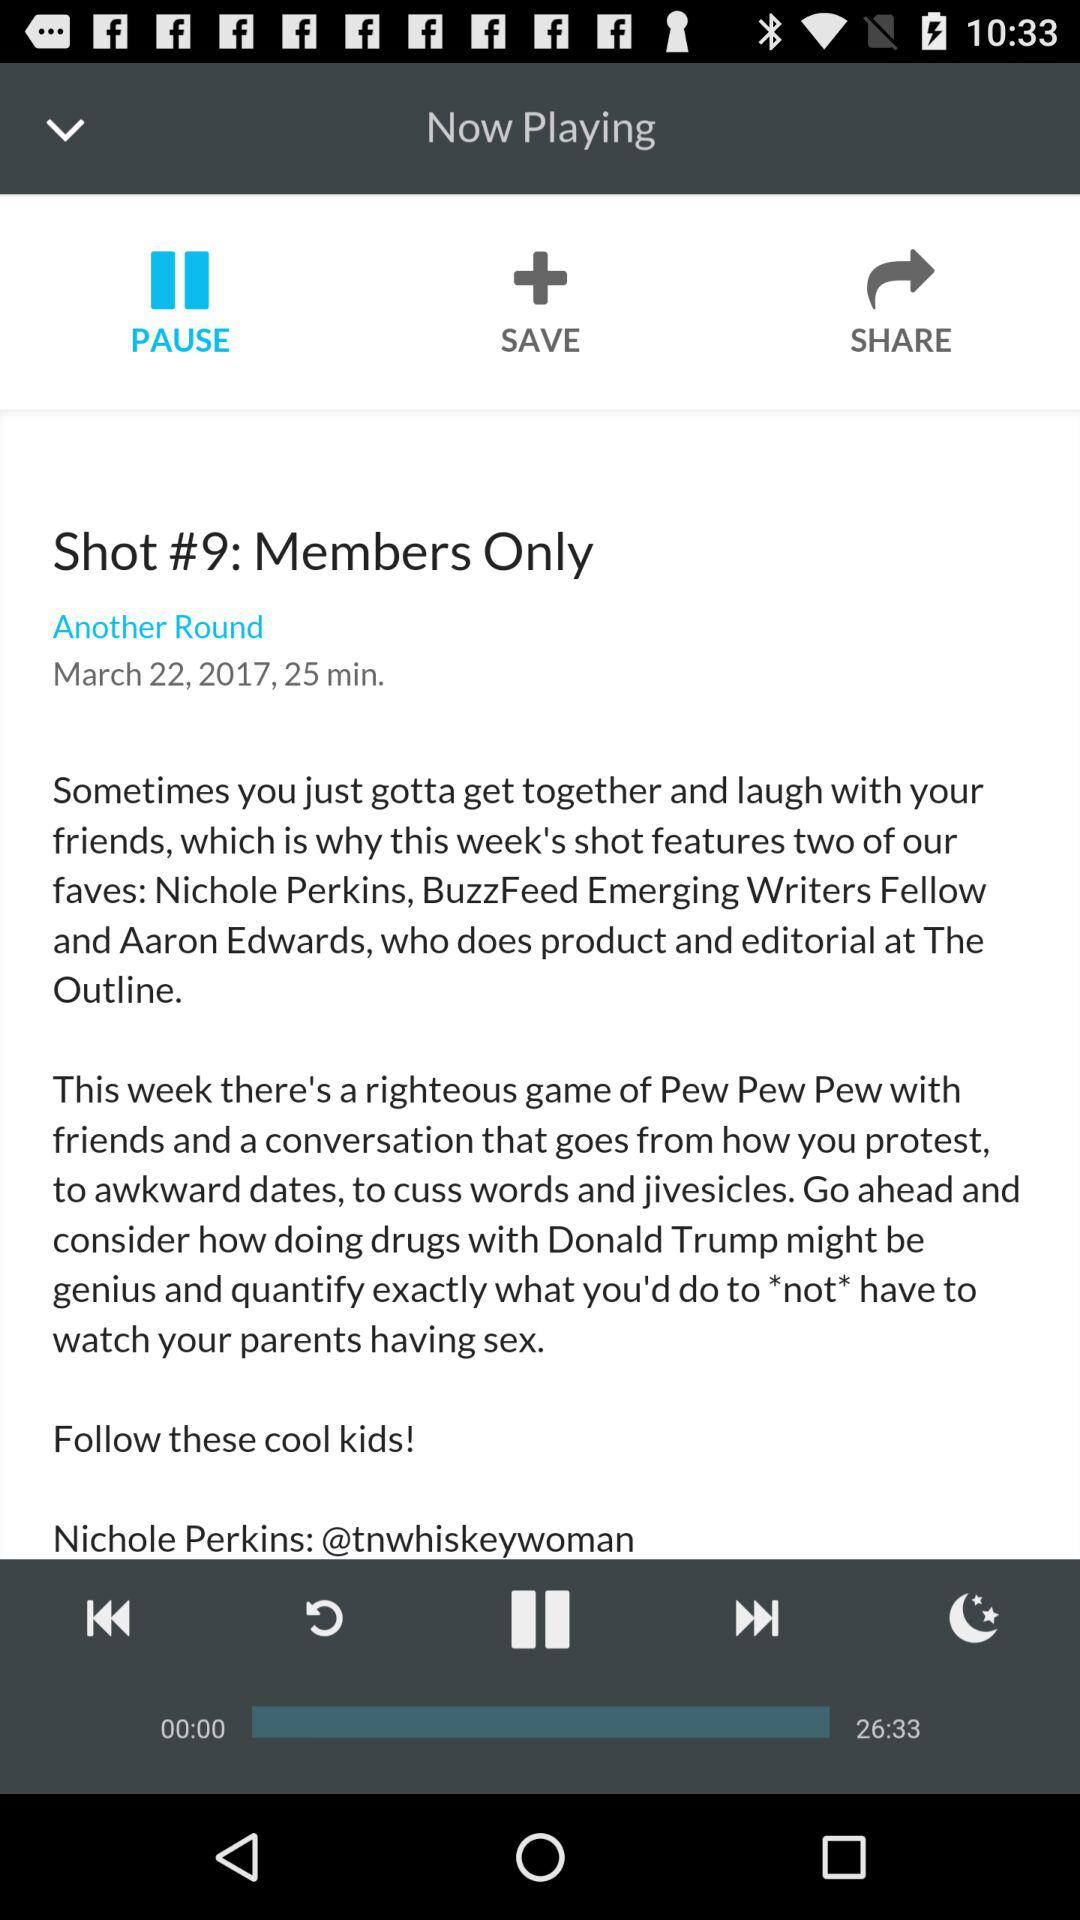What is the time duration of the current playing track? The time duration is "26:33". 